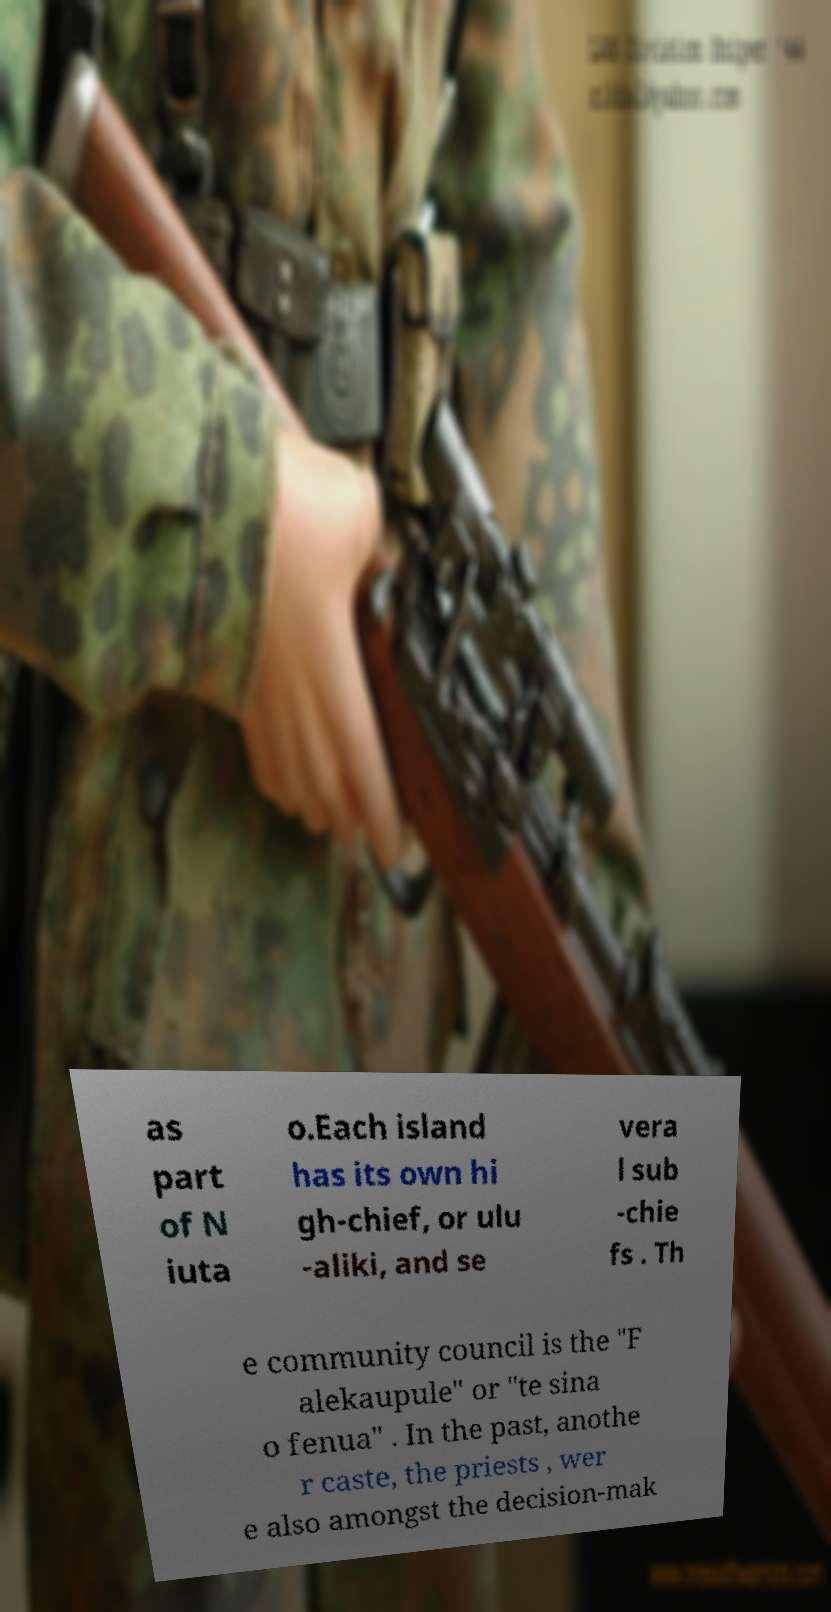I need the written content from this picture converted into text. Can you do that? as part of N iuta o.Each island has its own hi gh-chief, or ulu -aliki, and se vera l sub -chie fs . Th e community council is the "F alekaupule" or "te sina o fenua" . In the past, anothe r caste, the priests , wer e also amongst the decision-mak 